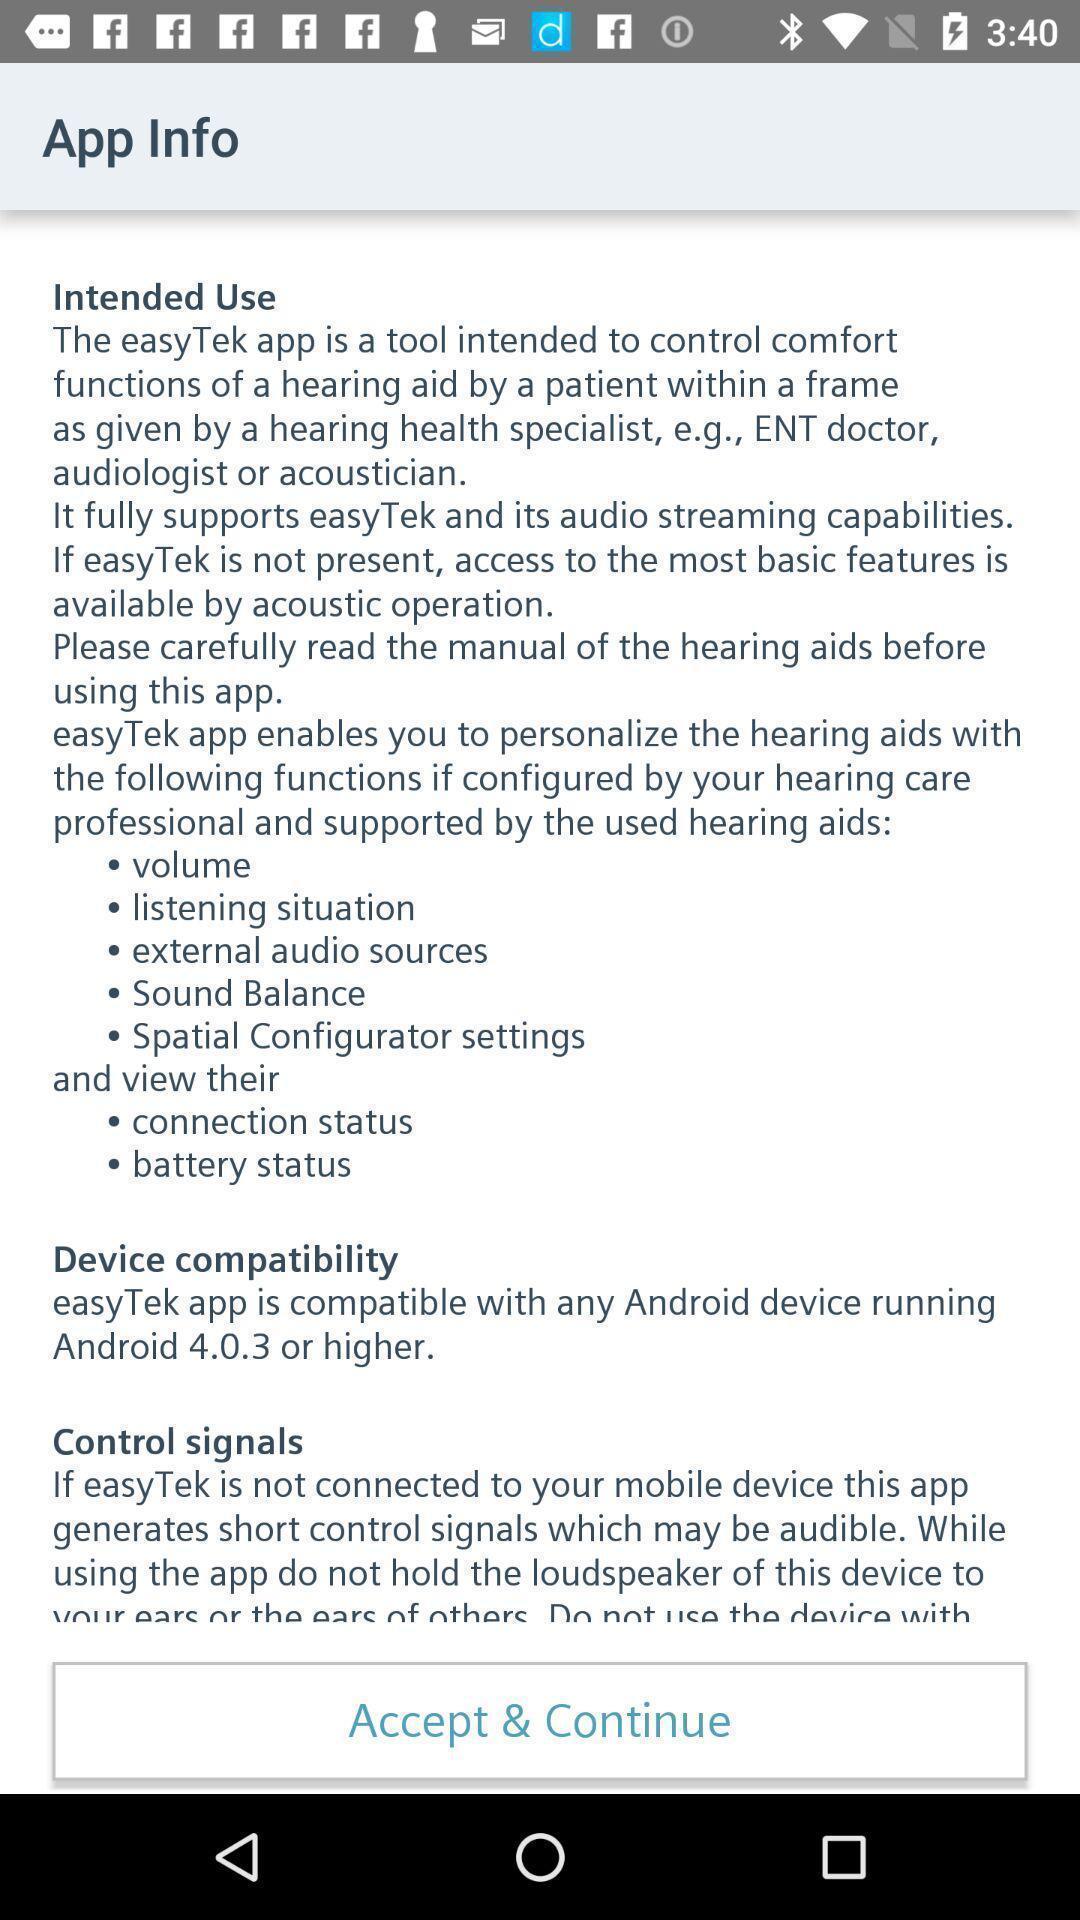What details can you identify in this image? Screen displaying information about the application. 